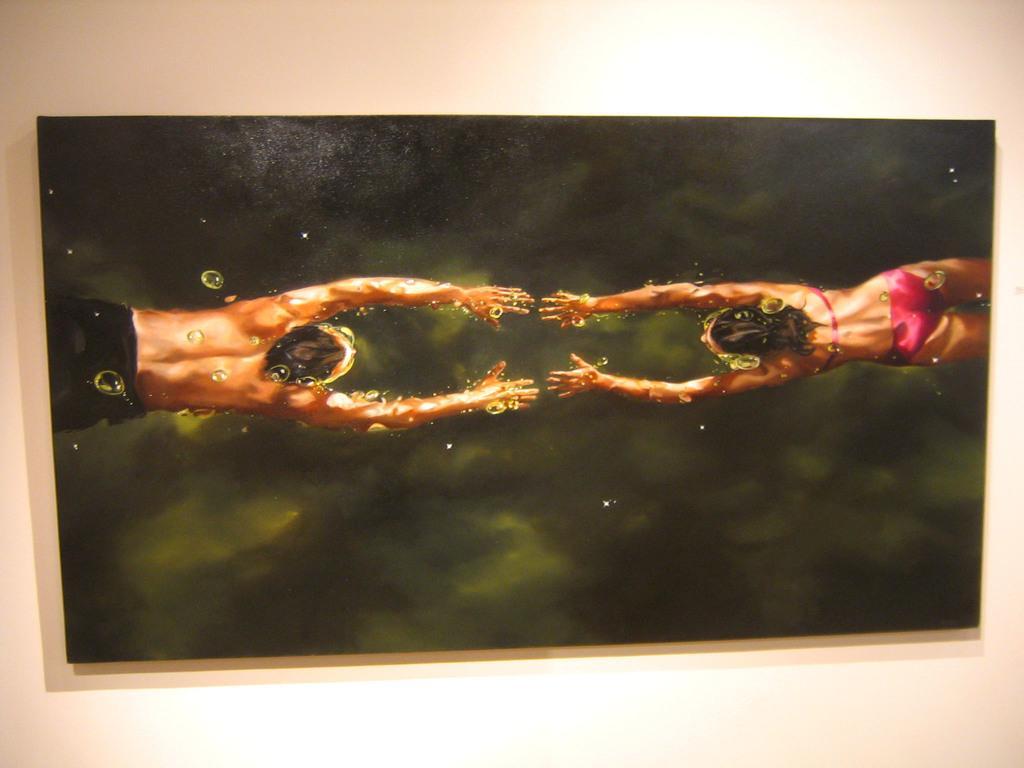Please provide a concise description of this image. In this picture we can see a frame. On this frame we can see painting of a woman and a man. In the background there is a wall. 